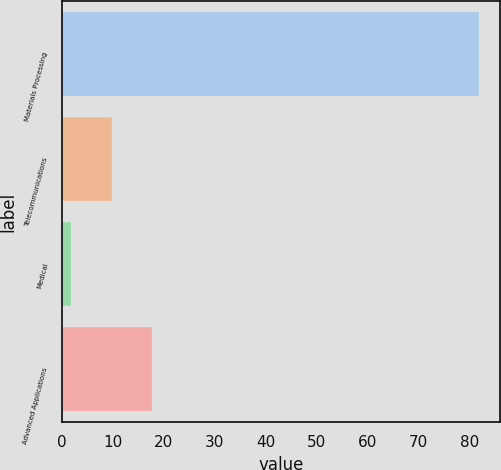Convert chart. <chart><loc_0><loc_0><loc_500><loc_500><bar_chart><fcel>Materials Processing<fcel>Telecommunications<fcel>Medical<fcel>Advanced Applications<nl><fcel>81.9<fcel>9.72<fcel>1.7<fcel>17.74<nl></chart> 